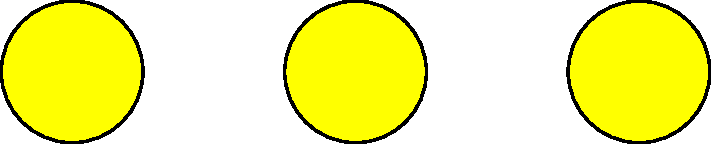As a blogger focused on creating a positive online environment for children, you're developing an educational game. Match the correct number to each group of child-friendly objects in the image. Which letter corresponds to the group that matches the number 3? To solve this problem, we need to count the objects in each group and match them to the given numbers:

1. Group A (top row): There are 3 yellow circles.
2. Group B (middle row): There are 2 red squares.
3. Group C (bottom row): There are 4 green ovals.

Now, let's match these counts to the numbers on the left side of the image:

- The number 3 matches Group A (3 yellow circles)
- The number 2 matches Group B (2 red squares)
- The number 4 matches Group C (4 green ovals)

The question asks which letter corresponds to the group that matches the number 3. We can see that Group A, labeled with the letter A, has 3 objects and matches the number 3.
Answer: A 